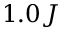Convert formula to latex. <formula><loc_0><loc_0><loc_500><loc_500>1 . 0 J</formula> 